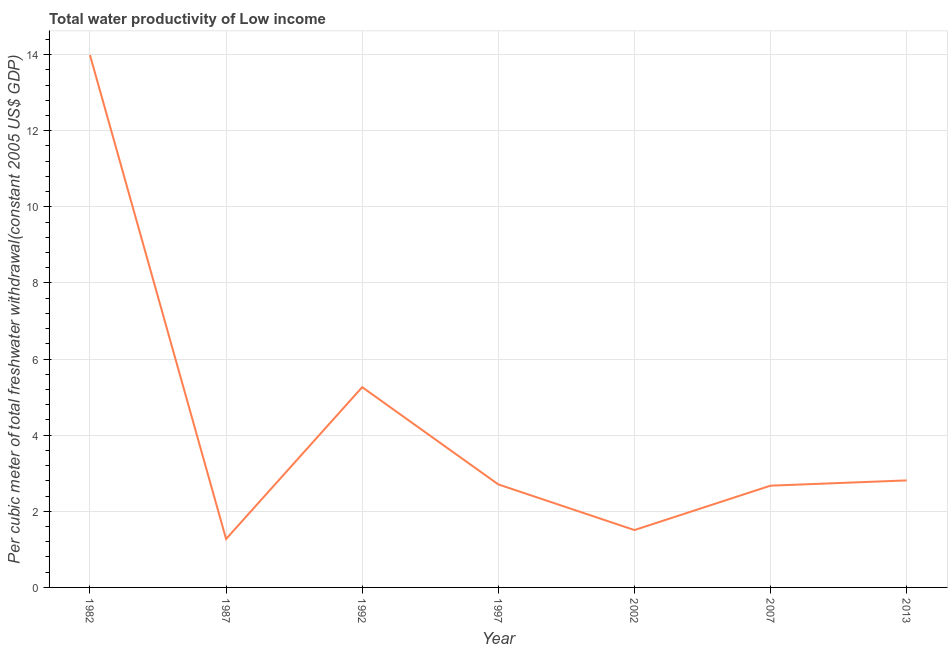What is the total water productivity in 2002?
Your answer should be compact. 1.51. Across all years, what is the maximum total water productivity?
Your answer should be compact. 13.99. Across all years, what is the minimum total water productivity?
Provide a succinct answer. 1.27. In which year was the total water productivity minimum?
Provide a succinct answer. 1987. What is the sum of the total water productivity?
Provide a succinct answer. 30.22. What is the difference between the total water productivity in 1987 and 1997?
Make the answer very short. -1.43. What is the average total water productivity per year?
Your response must be concise. 4.32. What is the median total water productivity?
Keep it short and to the point. 2.71. In how many years, is the total water productivity greater than 4 US$?
Provide a short and direct response. 2. What is the ratio of the total water productivity in 1997 to that in 2013?
Your answer should be very brief. 0.96. Is the total water productivity in 2007 less than that in 2013?
Your response must be concise. Yes. Is the difference between the total water productivity in 1997 and 2007 greater than the difference between any two years?
Provide a succinct answer. No. What is the difference between the highest and the second highest total water productivity?
Make the answer very short. 8.73. What is the difference between the highest and the lowest total water productivity?
Your response must be concise. 12.72. How many lines are there?
Provide a succinct answer. 1. What is the difference between two consecutive major ticks on the Y-axis?
Your answer should be very brief. 2. Does the graph contain any zero values?
Ensure brevity in your answer.  No. Does the graph contain grids?
Ensure brevity in your answer.  Yes. What is the title of the graph?
Provide a succinct answer. Total water productivity of Low income. What is the label or title of the Y-axis?
Your answer should be very brief. Per cubic meter of total freshwater withdrawal(constant 2005 US$ GDP). What is the Per cubic meter of total freshwater withdrawal(constant 2005 US$ GDP) of 1982?
Give a very brief answer. 13.99. What is the Per cubic meter of total freshwater withdrawal(constant 2005 US$ GDP) in 1987?
Your answer should be very brief. 1.27. What is the Per cubic meter of total freshwater withdrawal(constant 2005 US$ GDP) in 1992?
Your answer should be compact. 5.26. What is the Per cubic meter of total freshwater withdrawal(constant 2005 US$ GDP) of 1997?
Provide a short and direct response. 2.71. What is the Per cubic meter of total freshwater withdrawal(constant 2005 US$ GDP) in 2002?
Make the answer very short. 1.51. What is the Per cubic meter of total freshwater withdrawal(constant 2005 US$ GDP) of 2007?
Offer a very short reply. 2.67. What is the Per cubic meter of total freshwater withdrawal(constant 2005 US$ GDP) in 2013?
Offer a very short reply. 2.81. What is the difference between the Per cubic meter of total freshwater withdrawal(constant 2005 US$ GDP) in 1982 and 1987?
Offer a terse response. 12.72. What is the difference between the Per cubic meter of total freshwater withdrawal(constant 2005 US$ GDP) in 1982 and 1992?
Offer a very short reply. 8.73. What is the difference between the Per cubic meter of total freshwater withdrawal(constant 2005 US$ GDP) in 1982 and 1997?
Provide a succinct answer. 11.28. What is the difference between the Per cubic meter of total freshwater withdrawal(constant 2005 US$ GDP) in 1982 and 2002?
Offer a very short reply. 12.48. What is the difference between the Per cubic meter of total freshwater withdrawal(constant 2005 US$ GDP) in 1982 and 2007?
Offer a very short reply. 11.32. What is the difference between the Per cubic meter of total freshwater withdrawal(constant 2005 US$ GDP) in 1982 and 2013?
Make the answer very short. 11.18. What is the difference between the Per cubic meter of total freshwater withdrawal(constant 2005 US$ GDP) in 1987 and 1992?
Your response must be concise. -3.99. What is the difference between the Per cubic meter of total freshwater withdrawal(constant 2005 US$ GDP) in 1987 and 1997?
Keep it short and to the point. -1.43. What is the difference between the Per cubic meter of total freshwater withdrawal(constant 2005 US$ GDP) in 1987 and 2002?
Your response must be concise. -0.23. What is the difference between the Per cubic meter of total freshwater withdrawal(constant 2005 US$ GDP) in 1987 and 2007?
Provide a succinct answer. -1.4. What is the difference between the Per cubic meter of total freshwater withdrawal(constant 2005 US$ GDP) in 1987 and 2013?
Make the answer very short. -1.54. What is the difference between the Per cubic meter of total freshwater withdrawal(constant 2005 US$ GDP) in 1992 and 1997?
Give a very brief answer. 2.56. What is the difference between the Per cubic meter of total freshwater withdrawal(constant 2005 US$ GDP) in 1992 and 2002?
Your answer should be very brief. 3.75. What is the difference between the Per cubic meter of total freshwater withdrawal(constant 2005 US$ GDP) in 1992 and 2007?
Your answer should be very brief. 2.59. What is the difference between the Per cubic meter of total freshwater withdrawal(constant 2005 US$ GDP) in 1992 and 2013?
Your answer should be very brief. 2.45. What is the difference between the Per cubic meter of total freshwater withdrawal(constant 2005 US$ GDP) in 1997 and 2002?
Offer a very short reply. 1.2. What is the difference between the Per cubic meter of total freshwater withdrawal(constant 2005 US$ GDP) in 1997 and 2007?
Offer a very short reply. 0.03. What is the difference between the Per cubic meter of total freshwater withdrawal(constant 2005 US$ GDP) in 1997 and 2013?
Give a very brief answer. -0.11. What is the difference between the Per cubic meter of total freshwater withdrawal(constant 2005 US$ GDP) in 2002 and 2007?
Provide a short and direct response. -1.17. What is the difference between the Per cubic meter of total freshwater withdrawal(constant 2005 US$ GDP) in 2002 and 2013?
Provide a short and direct response. -1.3. What is the difference between the Per cubic meter of total freshwater withdrawal(constant 2005 US$ GDP) in 2007 and 2013?
Give a very brief answer. -0.14. What is the ratio of the Per cubic meter of total freshwater withdrawal(constant 2005 US$ GDP) in 1982 to that in 1987?
Your response must be concise. 10.99. What is the ratio of the Per cubic meter of total freshwater withdrawal(constant 2005 US$ GDP) in 1982 to that in 1992?
Ensure brevity in your answer.  2.66. What is the ratio of the Per cubic meter of total freshwater withdrawal(constant 2005 US$ GDP) in 1982 to that in 1997?
Offer a very short reply. 5.17. What is the ratio of the Per cubic meter of total freshwater withdrawal(constant 2005 US$ GDP) in 1982 to that in 2002?
Offer a very short reply. 9.28. What is the ratio of the Per cubic meter of total freshwater withdrawal(constant 2005 US$ GDP) in 1982 to that in 2007?
Offer a terse response. 5.23. What is the ratio of the Per cubic meter of total freshwater withdrawal(constant 2005 US$ GDP) in 1982 to that in 2013?
Make the answer very short. 4.97. What is the ratio of the Per cubic meter of total freshwater withdrawal(constant 2005 US$ GDP) in 1987 to that in 1992?
Make the answer very short. 0.24. What is the ratio of the Per cubic meter of total freshwater withdrawal(constant 2005 US$ GDP) in 1987 to that in 1997?
Provide a succinct answer. 0.47. What is the ratio of the Per cubic meter of total freshwater withdrawal(constant 2005 US$ GDP) in 1987 to that in 2002?
Offer a very short reply. 0.84. What is the ratio of the Per cubic meter of total freshwater withdrawal(constant 2005 US$ GDP) in 1987 to that in 2007?
Provide a succinct answer. 0.48. What is the ratio of the Per cubic meter of total freshwater withdrawal(constant 2005 US$ GDP) in 1987 to that in 2013?
Ensure brevity in your answer.  0.45. What is the ratio of the Per cubic meter of total freshwater withdrawal(constant 2005 US$ GDP) in 1992 to that in 1997?
Provide a succinct answer. 1.94. What is the ratio of the Per cubic meter of total freshwater withdrawal(constant 2005 US$ GDP) in 1992 to that in 2002?
Your answer should be compact. 3.49. What is the ratio of the Per cubic meter of total freshwater withdrawal(constant 2005 US$ GDP) in 1992 to that in 2007?
Offer a terse response. 1.97. What is the ratio of the Per cubic meter of total freshwater withdrawal(constant 2005 US$ GDP) in 1992 to that in 2013?
Provide a succinct answer. 1.87. What is the ratio of the Per cubic meter of total freshwater withdrawal(constant 2005 US$ GDP) in 1997 to that in 2002?
Your answer should be compact. 1.8. What is the ratio of the Per cubic meter of total freshwater withdrawal(constant 2005 US$ GDP) in 1997 to that in 2007?
Your answer should be compact. 1.01. What is the ratio of the Per cubic meter of total freshwater withdrawal(constant 2005 US$ GDP) in 2002 to that in 2007?
Your response must be concise. 0.56. What is the ratio of the Per cubic meter of total freshwater withdrawal(constant 2005 US$ GDP) in 2002 to that in 2013?
Your answer should be compact. 0.54. What is the ratio of the Per cubic meter of total freshwater withdrawal(constant 2005 US$ GDP) in 2007 to that in 2013?
Offer a terse response. 0.95. 